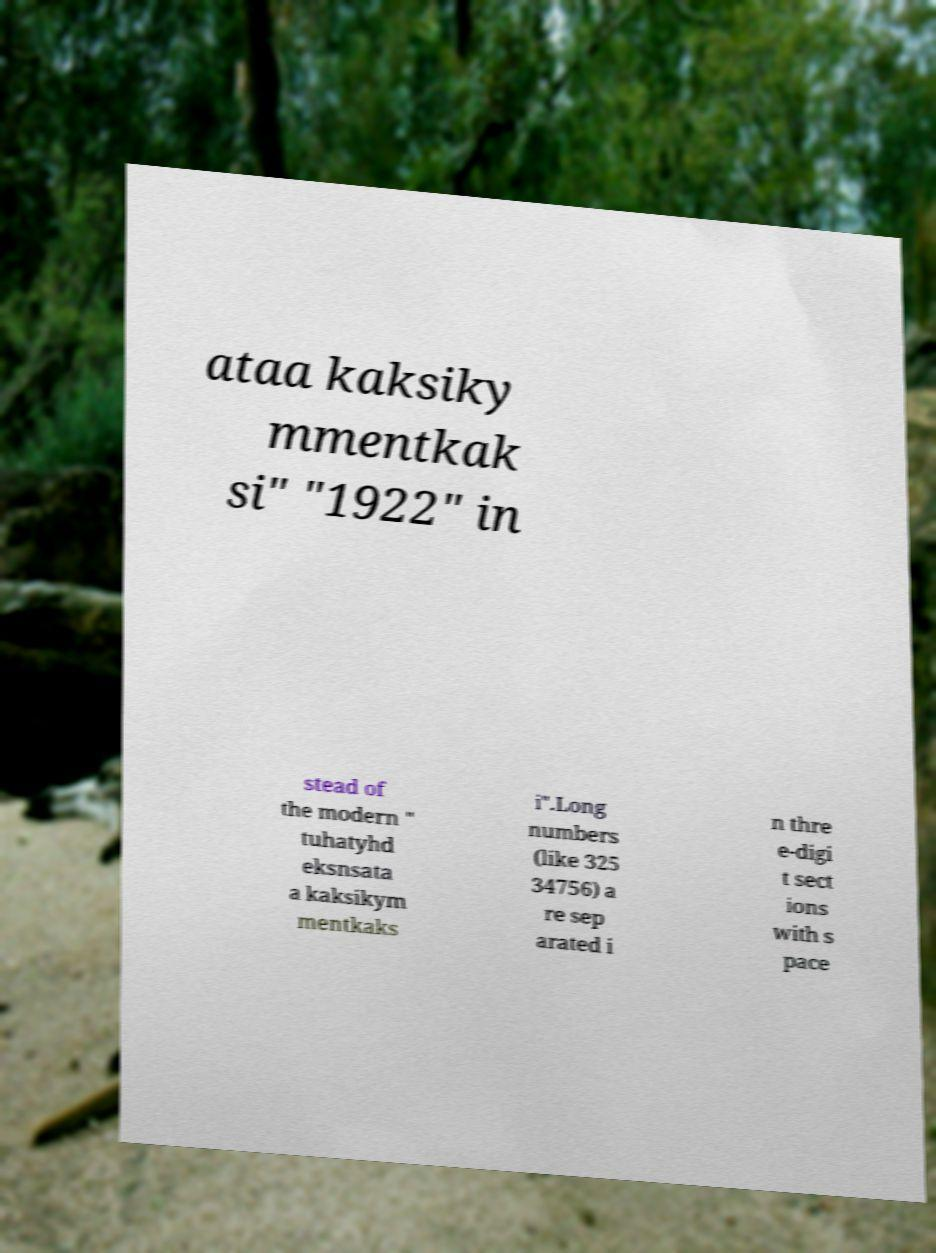I need the written content from this picture converted into text. Can you do that? ataa kaksiky mmentkak si" "1922" in stead of the modern " tuhatyhd eksnsata a kaksikym mentkaks i".Long numbers (like 325 34756) a re sep arated i n thre e-digi t sect ions with s pace 